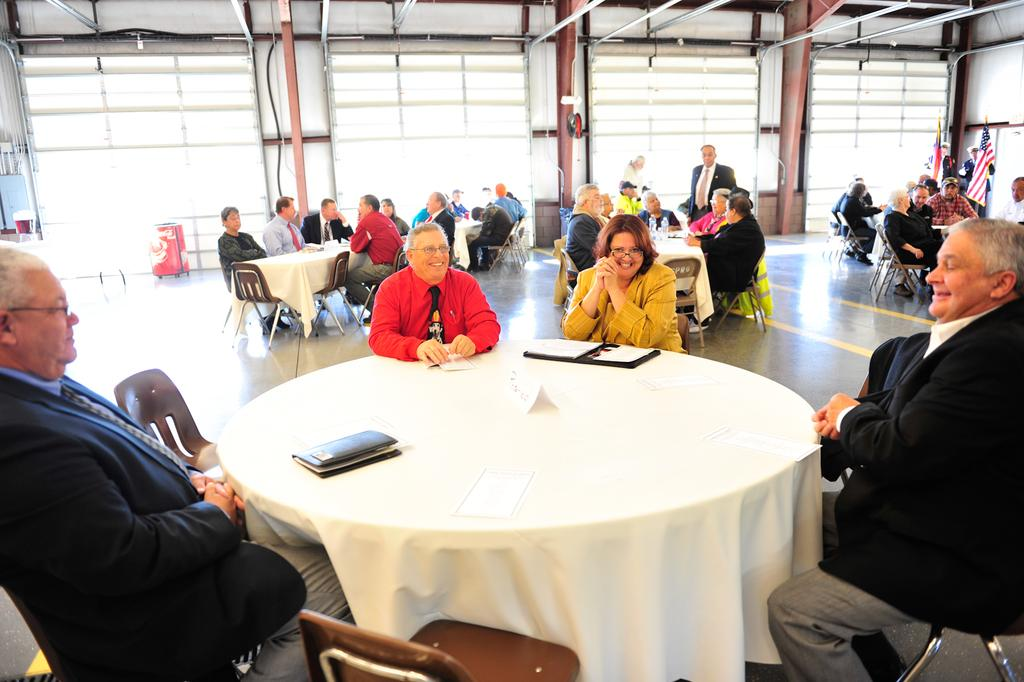How many persons can be seen sitting in the image? There are many persons sitting on chairs in the image. What type of furniture is present in the image? There are many tables and chairs in the image. What items can be seen on the tables? Books are on the tables in the image. What can be seen in the background of the image? In the background, there are flags, windows, tubes, and a suitcase. What rule does the boy break in the image? There is no boy present in the image, and therefore no rule-breaking can be observed. What type of cannon is visible in the image? There is no cannon present in the image. 